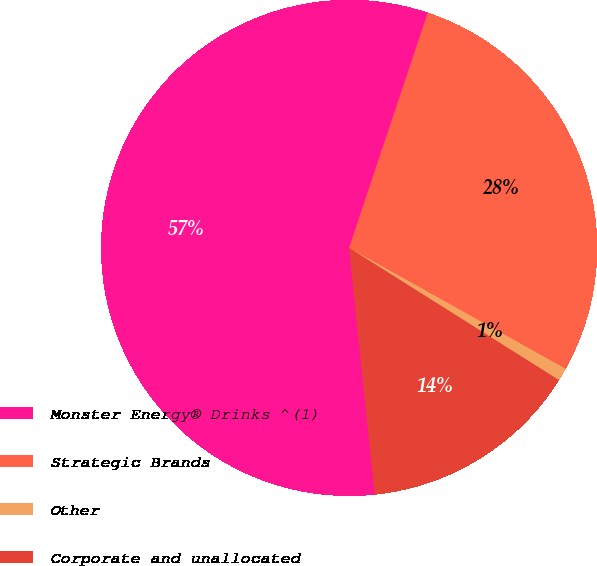Convert chart. <chart><loc_0><loc_0><loc_500><loc_500><pie_chart><fcel>Monster Energy® Drinks ^(1)<fcel>Strategic Brands<fcel>Other<fcel>Corporate and unallocated<nl><fcel>56.79%<fcel>27.97%<fcel>0.84%<fcel>14.4%<nl></chart> 